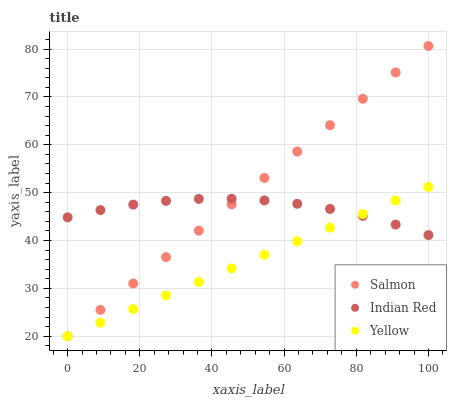Does Yellow have the minimum area under the curve?
Answer yes or no. Yes. Does Salmon have the maximum area under the curve?
Answer yes or no. Yes. Does Indian Red have the minimum area under the curve?
Answer yes or no. No. Does Indian Red have the maximum area under the curve?
Answer yes or no. No. Is Yellow the smoothest?
Answer yes or no. Yes. Is Indian Red the roughest?
Answer yes or no. Yes. Is Indian Red the smoothest?
Answer yes or no. No. Is Yellow the roughest?
Answer yes or no. No. Does Salmon have the lowest value?
Answer yes or no. Yes. Does Indian Red have the lowest value?
Answer yes or no. No. Does Salmon have the highest value?
Answer yes or no. Yes. Does Yellow have the highest value?
Answer yes or no. No. Does Salmon intersect Yellow?
Answer yes or no. Yes. Is Salmon less than Yellow?
Answer yes or no. No. Is Salmon greater than Yellow?
Answer yes or no. No. 